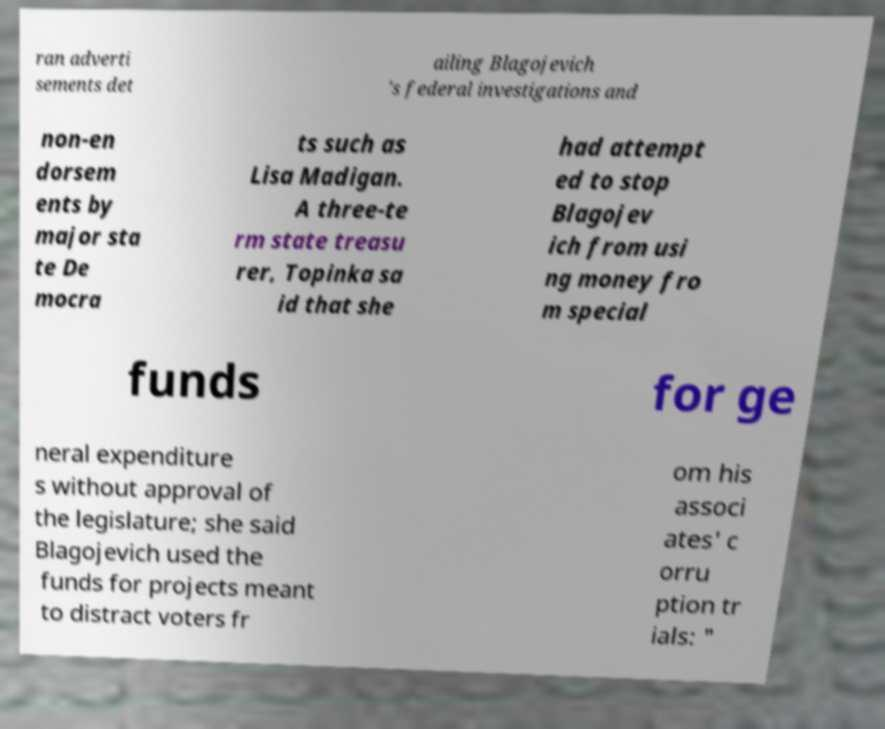Could you extract and type out the text from this image? ran adverti sements det ailing Blagojevich 's federal investigations and non-en dorsem ents by major sta te De mocra ts such as Lisa Madigan. A three-te rm state treasu rer, Topinka sa id that she had attempt ed to stop Blagojev ich from usi ng money fro m special funds for ge neral expenditure s without approval of the legislature; she said Blagojevich used the funds for projects meant to distract voters fr om his associ ates' c orru ption tr ials: " 